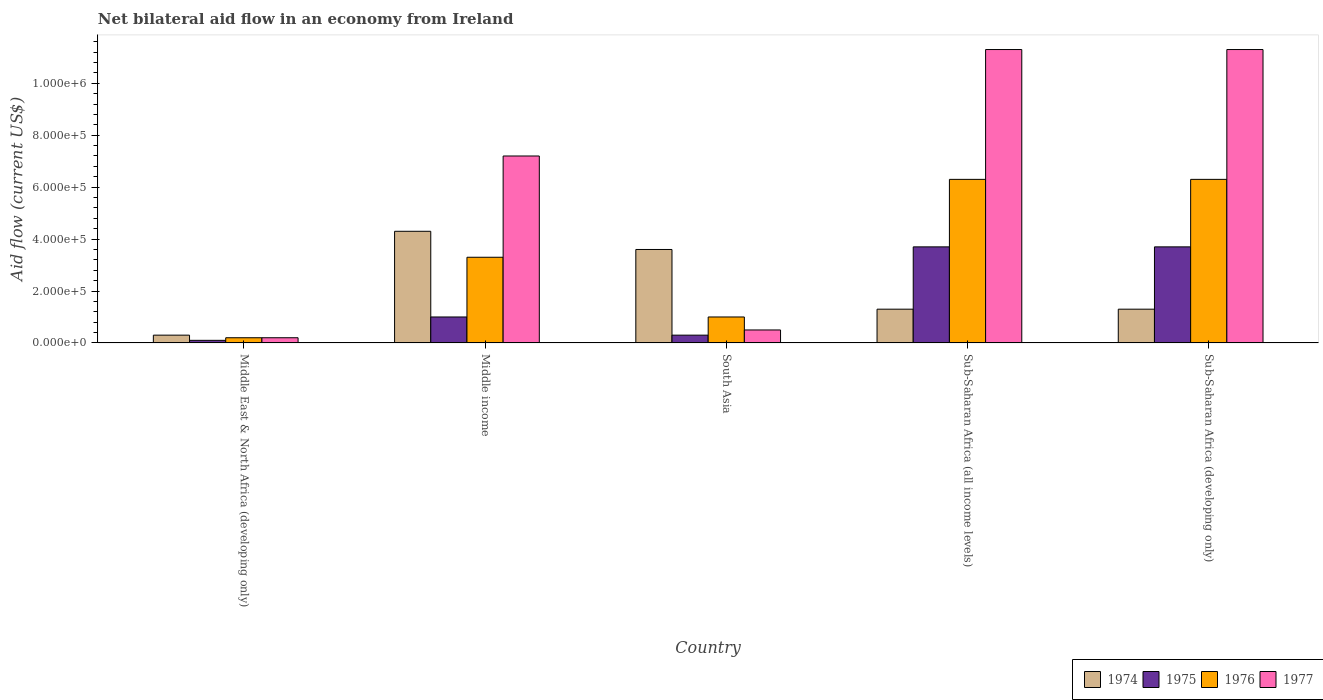How many different coloured bars are there?
Your answer should be very brief. 4. Are the number of bars on each tick of the X-axis equal?
Your response must be concise. Yes. What is the label of the 2nd group of bars from the left?
Give a very brief answer. Middle income. In how many cases, is the number of bars for a given country not equal to the number of legend labels?
Offer a terse response. 0. What is the net bilateral aid flow in 1977 in Middle income?
Provide a short and direct response. 7.20e+05. Across all countries, what is the maximum net bilateral aid flow in 1974?
Offer a terse response. 4.30e+05. Across all countries, what is the minimum net bilateral aid flow in 1976?
Provide a succinct answer. 2.00e+04. In which country was the net bilateral aid flow in 1975 maximum?
Offer a very short reply. Sub-Saharan Africa (all income levels). In which country was the net bilateral aid flow in 1976 minimum?
Offer a terse response. Middle East & North Africa (developing only). What is the total net bilateral aid flow in 1977 in the graph?
Give a very brief answer. 3.05e+06. What is the difference between the net bilateral aid flow in 1976 in South Asia and that in Sub-Saharan Africa (developing only)?
Ensure brevity in your answer.  -5.30e+05. What is the difference between the net bilateral aid flow in 1974 in Sub-Saharan Africa (all income levels) and the net bilateral aid flow in 1977 in Middle East & North Africa (developing only)?
Your response must be concise. 1.10e+05. What is the average net bilateral aid flow in 1976 per country?
Make the answer very short. 3.42e+05. What is the difference between the net bilateral aid flow of/in 1976 and net bilateral aid flow of/in 1977 in Sub-Saharan Africa (all income levels)?
Offer a terse response. -5.00e+05. What is the ratio of the net bilateral aid flow in 1974 in South Asia to that in Sub-Saharan Africa (developing only)?
Make the answer very short. 2.77. Is the difference between the net bilateral aid flow in 1976 in Middle income and South Asia greater than the difference between the net bilateral aid flow in 1977 in Middle income and South Asia?
Give a very brief answer. No. What is the difference between the highest and the lowest net bilateral aid flow in 1976?
Provide a succinct answer. 6.10e+05. Is the sum of the net bilateral aid flow in 1975 in South Asia and Sub-Saharan Africa (all income levels) greater than the maximum net bilateral aid flow in 1974 across all countries?
Keep it short and to the point. No. What does the 1st bar from the left in Sub-Saharan Africa (developing only) represents?
Provide a short and direct response. 1974. What does the 4th bar from the right in Middle income represents?
Your answer should be compact. 1974. Does the graph contain grids?
Keep it short and to the point. No. Where does the legend appear in the graph?
Your answer should be compact. Bottom right. What is the title of the graph?
Offer a very short reply. Net bilateral aid flow in an economy from Ireland. Does "1974" appear as one of the legend labels in the graph?
Your response must be concise. Yes. What is the label or title of the X-axis?
Offer a terse response. Country. What is the label or title of the Y-axis?
Ensure brevity in your answer.  Aid flow (current US$). What is the Aid flow (current US$) of 1974 in Middle East & North Africa (developing only)?
Offer a terse response. 3.00e+04. What is the Aid flow (current US$) in 1977 in Middle East & North Africa (developing only)?
Your answer should be very brief. 2.00e+04. What is the Aid flow (current US$) of 1974 in Middle income?
Keep it short and to the point. 4.30e+05. What is the Aid flow (current US$) of 1976 in Middle income?
Provide a succinct answer. 3.30e+05. What is the Aid flow (current US$) of 1977 in Middle income?
Keep it short and to the point. 7.20e+05. What is the Aid flow (current US$) in 1974 in South Asia?
Your response must be concise. 3.60e+05. What is the Aid flow (current US$) in 1975 in South Asia?
Give a very brief answer. 3.00e+04. What is the Aid flow (current US$) of 1977 in South Asia?
Your answer should be compact. 5.00e+04. What is the Aid flow (current US$) in 1974 in Sub-Saharan Africa (all income levels)?
Your answer should be very brief. 1.30e+05. What is the Aid flow (current US$) in 1975 in Sub-Saharan Africa (all income levels)?
Provide a succinct answer. 3.70e+05. What is the Aid flow (current US$) of 1976 in Sub-Saharan Africa (all income levels)?
Offer a very short reply. 6.30e+05. What is the Aid flow (current US$) of 1977 in Sub-Saharan Africa (all income levels)?
Offer a very short reply. 1.13e+06. What is the Aid flow (current US$) in 1975 in Sub-Saharan Africa (developing only)?
Provide a short and direct response. 3.70e+05. What is the Aid flow (current US$) in 1976 in Sub-Saharan Africa (developing only)?
Your answer should be very brief. 6.30e+05. What is the Aid flow (current US$) in 1977 in Sub-Saharan Africa (developing only)?
Provide a succinct answer. 1.13e+06. Across all countries, what is the maximum Aid flow (current US$) of 1975?
Your answer should be compact. 3.70e+05. Across all countries, what is the maximum Aid flow (current US$) of 1976?
Ensure brevity in your answer.  6.30e+05. Across all countries, what is the maximum Aid flow (current US$) in 1977?
Your answer should be very brief. 1.13e+06. Across all countries, what is the minimum Aid flow (current US$) of 1976?
Keep it short and to the point. 2.00e+04. Across all countries, what is the minimum Aid flow (current US$) in 1977?
Keep it short and to the point. 2.00e+04. What is the total Aid flow (current US$) of 1974 in the graph?
Offer a very short reply. 1.08e+06. What is the total Aid flow (current US$) in 1975 in the graph?
Keep it short and to the point. 8.80e+05. What is the total Aid flow (current US$) in 1976 in the graph?
Give a very brief answer. 1.71e+06. What is the total Aid flow (current US$) in 1977 in the graph?
Offer a terse response. 3.05e+06. What is the difference between the Aid flow (current US$) of 1974 in Middle East & North Africa (developing only) and that in Middle income?
Provide a short and direct response. -4.00e+05. What is the difference between the Aid flow (current US$) in 1975 in Middle East & North Africa (developing only) and that in Middle income?
Provide a short and direct response. -9.00e+04. What is the difference between the Aid flow (current US$) of 1976 in Middle East & North Africa (developing only) and that in Middle income?
Your answer should be very brief. -3.10e+05. What is the difference between the Aid flow (current US$) of 1977 in Middle East & North Africa (developing only) and that in Middle income?
Keep it short and to the point. -7.00e+05. What is the difference between the Aid flow (current US$) in 1974 in Middle East & North Africa (developing only) and that in South Asia?
Give a very brief answer. -3.30e+05. What is the difference between the Aid flow (current US$) in 1975 in Middle East & North Africa (developing only) and that in South Asia?
Your response must be concise. -2.00e+04. What is the difference between the Aid flow (current US$) of 1977 in Middle East & North Africa (developing only) and that in South Asia?
Ensure brevity in your answer.  -3.00e+04. What is the difference between the Aid flow (current US$) in 1975 in Middle East & North Africa (developing only) and that in Sub-Saharan Africa (all income levels)?
Your response must be concise. -3.60e+05. What is the difference between the Aid flow (current US$) in 1976 in Middle East & North Africa (developing only) and that in Sub-Saharan Africa (all income levels)?
Give a very brief answer. -6.10e+05. What is the difference between the Aid flow (current US$) of 1977 in Middle East & North Africa (developing only) and that in Sub-Saharan Africa (all income levels)?
Make the answer very short. -1.11e+06. What is the difference between the Aid flow (current US$) in 1974 in Middle East & North Africa (developing only) and that in Sub-Saharan Africa (developing only)?
Offer a terse response. -1.00e+05. What is the difference between the Aid flow (current US$) of 1975 in Middle East & North Africa (developing only) and that in Sub-Saharan Africa (developing only)?
Offer a very short reply. -3.60e+05. What is the difference between the Aid flow (current US$) in 1976 in Middle East & North Africa (developing only) and that in Sub-Saharan Africa (developing only)?
Provide a short and direct response. -6.10e+05. What is the difference between the Aid flow (current US$) of 1977 in Middle East & North Africa (developing only) and that in Sub-Saharan Africa (developing only)?
Keep it short and to the point. -1.11e+06. What is the difference between the Aid flow (current US$) of 1975 in Middle income and that in South Asia?
Ensure brevity in your answer.  7.00e+04. What is the difference between the Aid flow (current US$) in 1977 in Middle income and that in South Asia?
Your response must be concise. 6.70e+05. What is the difference between the Aid flow (current US$) of 1974 in Middle income and that in Sub-Saharan Africa (all income levels)?
Your answer should be very brief. 3.00e+05. What is the difference between the Aid flow (current US$) of 1976 in Middle income and that in Sub-Saharan Africa (all income levels)?
Provide a succinct answer. -3.00e+05. What is the difference between the Aid flow (current US$) of 1977 in Middle income and that in Sub-Saharan Africa (all income levels)?
Ensure brevity in your answer.  -4.10e+05. What is the difference between the Aid flow (current US$) of 1976 in Middle income and that in Sub-Saharan Africa (developing only)?
Your answer should be very brief. -3.00e+05. What is the difference between the Aid flow (current US$) in 1977 in Middle income and that in Sub-Saharan Africa (developing only)?
Offer a very short reply. -4.10e+05. What is the difference between the Aid flow (current US$) in 1976 in South Asia and that in Sub-Saharan Africa (all income levels)?
Your response must be concise. -5.30e+05. What is the difference between the Aid flow (current US$) in 1977 in South Asia and that in Sub-Saharan Africa (all income levels)?
Provide a short and direct response. -1.08e+06. What is the difference between the Aid flow (current US$) of 1974 in South Asia and that in Sub-Saharan Africa (developing only)?
Provide a short and direct response. 2.30e+05. What is the difference between the Aid flow (current US$) of 1975 in South Asia and that in Sub-Saharan Africa (developing only)?
Offer a very short reply. -3.40e+05. What is the difference between the Aid flow (current US$) of 1976 in South Asia and that in Sub-Saharan Africa (developing only)?
Offer a terse response. -5.30e+05. What is the difference between the Aid flow (current US$) in 1977 in South Asia and that in Sub-Saharan Africa (developing only)?
Give a very brief answer. -1.08e+06. What is the difference between the Aid flow (current US$) in 1975 in Sub-Saharan Africa (all income levels) and that in Sub-Saharan Africa (developing only)?
Make the answer very short. 0. What is the difference between the Aid flow (current US$) in 1977 in Sub-Saharan Africa (all income levels) and that in Sub-Saharan Africa (developing only)?
Your answer should be very brief. 0. What is the difference between the Aid flow (current US$) in 1974 in Middle East & North Africa (developing only) and the Aid flow (current US$) in 1976 in Middle income?
Ensure brevity in your answer.  -3.00e+05. What is the difference between the Aid flow (current US$) in 1974 in Middle East & North Africa (developing only) and the Aid flow (current US$) in 1977 in Middle income?
Give a very brief answer. -6.90e+05. What is the difference between the Aid flow (current US$) in 1975 in Middle East & North Africa (developing only) and the Aid flow (current US$) in 1976 in Middle income?
Make the answer very short. -3.20e+05. What is the difference between the Aid flow (current US$) of 1975 in Middle East & North Africa (developing only) and the Aid flow (current US$) of 1977 in Middle income?
Your response must be concise. -7.10e+05. What is the difference between the Aid flow (current US$) in 1976 in Middle East & North Africa (developing only) and the Aid flow (current US$) in 1977 in Middle income?
Offer a very short reply. -7.00e+05. What is the difference between the Aid flow (current US$) of 1974 in Middle East & North Africa (developing only) and the Aid flow (current US$) of 1975 in South Asia?
Keep it short and to the point. 0. What is the difference between the Aid flow (current US$) in 1974 in Middle East & North Africa (developing only) and the Aid flow (current US$) in 1976 in South Asia?
Offer a very short reply. -7.00e+04. What is the difference between the Aid flow (current US$) of 1975 in Middle East & North Africa (developing only) and the Aid flow (current US$) of 1976 in South Asia?
Provide a succinct answer. -9.00e+04. What is the difference between the Aid flow (current US$) in 1974 in Middle East & North Africa (developing only) and the Aid flow (current US$) in 1976 in Sub-Saharan Africa (all income levels)?
Offer a terse response. -6.00e+05. What is the difference between the Aid flow (current US$) in 1974 in Middle East & North Africa (developing only) and the Aid flow (current US$) in 1977 in Sub-Saharan Africa (all income levels)?
Make the answer very short. -1.10e+06. What is the difference between the Aid flow (current US$) of 1975 in Middle East & North Africa (developing only) and the Aid flow (current US$) of 1976 in Sub-Saharan Africa (all income levels)?
Your response must be concise. -6.20e+05. What is the difference between the Aid flow (current US$) in 1975 in Middle East & North Africa (developing only) and the Aid flow (current US$) in 1977 in Sub-Saharan Africa (all income levels)?
Your answer should be compact. -1.12e+06. What is the difference between the Aid flow (current US$) of 1976 in Middle East & North Africa (developing only) and the Aid flow (current US$) of 1977 in Sub-Saharan Africa (all income levels)?
Your answer should be very brief. -1.11e+06. What is the difference between the Aid flow (current US$) in 1974 in Middle East & North Africa (developing only) and the Aid flow (current US$) in 1976 in Sub-Saharan Africa (developing only)?
Offer a very short reply. -6.00e+05. What is the difference between the Aid flow (current US$) in 1974 in Middle East & North Africa (developing only) and the Aid flow (current US$) in 1977 in Sub-Saharan Africa (developing only)?
Your answer should be compact. -1.10e+06. What is the difference between the Aid flow (current US$) of 1975 in Middle East & North Africa (developing only) and the Aid flow (current US$) of 1976 in Sub-Saharan Africa (developing only)?
Give a very brief answer. -6.20e+05. What is the difference between the Aid flow (current US$) of 1975 in Middle East & North Africa (developing only) and the Aid flow (current US$) of 1977 in Sub-Saharan Africa (developing only)?
Give a very brief answer. -1.12e+06. What is the difference between the Aid flow (current US$) of 1976 in Middle East & North Africa (developing only) and the Aid flow (current US$) of 1977 in Sub-Saharan Africa (developing only)?
Ensure brevity in your answer.  -1.11e+06. What is the difference between the Aid flow (current US$) in 1974 in Middle income and the Aid flow (current US$) in 1975 in South Asia?
Provide a succinct answer. 4.00e+05. What is the difference between the Aid flow (current US$) of 1974 in Middle income and the Aid flow (current US$) of 1975 in Sub-Saharan Africa (all income levels)?
Provide a short and direct response. 6.00e+04. What is the difference between the Aid flow (current US$) of 1974 in Middle income and the Aid flow (current US$) of 1976 in Sub-Saharan Africa (all income levels)?
Give a very brief answer. -2.00e+05. What is the difference between the Aid flow (current US$) in 1974 in Middle income and the Aid flow (current US$) in 1977 in Sub-Saharan Africa (all income levels)?
Provide a succinct answer. -7.00e+05. What is the difference between the Aid flow (current US$) in 1975 in Middle income and the Aid flow (current US$) in 1976 in Sub-Saharan Africa (all income levels)?
Ensure brevity in your answer.  -5.30e+05. What is the difference between the Aid flow (current US$) of 1975 in Middle income and the Aid flow (current US$) of 1977 in Sub-Saharan Africa (all income levels)?
Your answer should be compact. -1.03e+06. What is the difference between the Aid flow (current US$) in 1976 in Middle income and the Aid flow (current US$) in 1977 in Sub-Saharan Africa (all income levels)?
Your answer should be very brief. -8.00e+05. What is the difference between the Aid flow (current US$) in 1974 in Middle income and the Aid flow (current US$) in 1976 in Sub-Saharan Africa (developing only)?
Give a very brief answer. -2.00e+05. What is the difference between the Aid flow (current US$) in 1974 in Middle income and the Aid flow (current US$) in 1977 in Sub-Saharan Africa (developing only)?
Offer a very short reply. -7.00e+05. What is the difference between the Aid flow (current US$) of 1975 in Middle income and the Aid flow (current US$) of 1976 in Sub-Saharan Africa (developing only)?
Your response must be concise. -5.30e+05. What is the difference between the Aid flow (current US$) in 1975 in Middle income and the Aid flow (current US$) in 1977 in Sub-Saharan Africa (developing only)?
Your response must be concise. -1.03e+06. What is the difference between the Aid flow (current US$) of 1976 in Middle income and the Aid flow (current US$) of 1977 in Sub-Saharan Africa (developing only)?
Provide a succinct answer. -8.00e+05. What is the difference between the Aid flow (current US$) of 1974 in South Asia and the Aid flow (current US$) of 1977 in Sub-Saharan Africa (all income levels)?
Make the answer very short. -7.70e+05. What is the difference between the Aid flow (current US$) of 1975 in South Asia and the Aid flow (current US$) of 1976 in Sub-Saharan Africa (all income levels)?
Your answer should be compact. -6.00e+05. What is the difference between the Aid flow (current US$) of 1975 in South Asia and the Aid flow (current US$) of 1977 in Sub-Saharan Africa (all income levels)?
Your response must be concise. -1.10e+06. What is the difference between the Aid flow (current US$) in 1976 in South Asia and the Aid flow (current US$) in 1977 in Sub-Saharan Africa (all income levels)?
Your answer should be very brief. -1.03e+06. What is the difference between the Aid flow (current US$) of 1974 in South Asia and the Aid flow (current US$) of 1977 in Sub-Saharan Africa (developing only)?
Ensure brevity in your answer.  -7.70e+05. What is the difference between the Aid flow (current US$) of 1975 in South Asia and the Aid flow (current US$) of 1976 in Sub-Saharan Africa (developing only)?
Your response must be concise. -6.00e+05. What is the difference between the Aid flow (current US$) of 1975 in South Asia and the Aid flow (current US$) of 1977 in Sub-Saharan Africa (developing only)?
Your response must be concise. -1.10e+06. What is the difference between the Aid flow (current US$) of 1976 in South Asia and the Aid flow (current US$) of 1977 in Sub-Saharan Africa (developing only)?
Give a very brief answer. -1.03e+06. What is the difference between the Aid flow (current US$) of 1974 in Sub-Saharan Africa (all income levels) and the Aid flow (current US$) of 1975 in Sub-Saharan Africa (developing only)?
Provide a short and direct response. -2.40e+05. What is the difference between the Aid flow (current US$) of 1974 in Sub-Saharan Africa (all income levels) and the Aid flow (current US$) of 1976 in Sub-Saharan Africa (developing only)?
Your response must be concise. -5.00e+05. What is the difference between the Aid flow (current US$) in 1975 in Sub-Saharan Africa (all income levels) and the Aid flow (current US$) in 1976 in Sub-Saharan Africa (developing only)?
Keep it short and to the point. -2.60e+05. What is the difference between the Aid flow (current US$) of 1975 in Sub-Saharan Africa (all income levels) and the Aid flow (current US$) of 1977 in Sub-Saharan Africa (developing only)?
Make the answer very short. -7.60e+05. What is the difference between the Aid flow (current US$) of 1976 in Sub-Saharan Africa (all income levels) and the Aid flow (current US$) of 1977 in Sub-Saharan Africa (developing only)?
Make the answer very short. -5.00e+05. What is the average Aid flow (current US$) in 1974 per country?
Provide a short and direct response. 2.16e+05. What is the average Aid flow (current US$) of 1975 per country?
Your response must be concise. 1.76e+05. What is the average Aid flow (current US$) in 1976 per country?
Give a very brief answer. 3.42e+05. What is the difference between the Aid flow (current US$) in 1974 and Aid flow (current US$) in 1977 in Middle East & North Africa (developing only)?
Give a very brief answer. 10000. What is the difference between the Aid flow (current US$) of 1976 and Aid flow (current US$) of 1977 in Middle East & North Africa (developing only)?
Your answer should be compact. 0. What is the difference between the Aid flow (current US$) of 1974 and Aid flow (current US$) of 1975 in Middle income?
Your answer should be very brief. 3.30e+05. What is the difference between the Aid flow (current US$) in 1974 and Aid flow (current US$) in 1976 in Middle income?
Your answer should be very brief. 1.00e+05. What is the difference between the Aid flow (current US$) in 1975 and Aid flow (current US$) in 1976 in Middle income?
Give a very brief answer. -2.30e+05. What is the difference between the Aid flow (current US$) of 1975 and Aid flow (current US$) of 1977 in Middle income?
Give a very brief answer. -6.20e+05. What is the difference between the Aid flow (current US$) in 1976 and Aid flow (current US$) in 1977 in Middle income?
Provide a short and direct response. -3.90e+05. What is the difference between the Aid flow (current US$) in 1974 and Aid flow (current US$) in 1976 in South Asia?
Your answer should be compact. 2.60e+05. What is the difference between the Aid flow (current US$) of 1975 and Aid flow (current US$) of 1977 in South Asia?
Your answer should be compact. -2.00e+04. What is the difference between the Aid flow (current US$) of 1974 and Aid flow (current US$) of 1976 in Sub-Saharan Africa (all income levels)?
Give a very brief answer. -5.00e+05. What is the difference between the Aid flow (current US$) of 1974 and Aid flow (current US$) of 1977 in Sub-Saharan Africa (all income levels)?
Offer a terse response. -1.00e+06. What is the difference between the Aid flow (current US$) of 1975 and Aid flow (current US$) of 1977 in Sub-Saharan Africa (all income levels)?
Your answer should be very brief. -7.60e+05. What is the difference between the Aid flow (current US$) in 1976 and Aid flow (current US$) in 1977 in Sub-Saharan Africa (all income levels)?
Keep it short and to the point. -5.00e+05. What is the difference between the Aid flow (current US$) of 1974 and Aid flow (current US$) of 1975 in Sub-Saharan Africa (developing only)?
Provide a short and direct response. -2.40e+05. What is the difference between the Aid flow (current US$) of 1974 and Aid flow (current US$) of 1976 in Sub-Saharan Africa (developing only)?
Ensure brevity in your answer.  -5.00e+05. What is the difference between the Aid flow (current US$) in 1974 and Aid flow (current US$) in 1977 in Sub-Saharan Africa (developing only)?
Make the answer very short. -1.00e+06. What is the difference between the Aid flow (current US$) of 1975 and Aid flow (current US$) of 1976 in Sub-Saharan Africa (developing only)?
Make the answer very short. -2.60e+05. What is the difference between the Aid flow (current US$) in 1975 and Aid flow (current US$) in 1977 in Sub-Saharan Africa (developing only)?
Make the answer very short. -7.60e+05. What is the difference between the Aid flow (current US$) of 1976 and Aid flow (current US$) of 1977 in Sub-Saharan Africa (developing only)?
Provide a short and direct response. -5.00e+05. What is the ratio of the Aid flow (current US$) in 1974 in Middle East & North Africa (developing only) to that in Middle income?
Keep it short and to the point. 0.07. What is the ratio of the Aid flow (current US$) in 1975 in Middle East & North Africa (developing only) to that in Middle income?
Ensure brevity in your answer.  0.1. What is the ratio of the Aid flow (current US$) in 1976 in Middle East & North Africa (developing only) to that in Middle income?
Make the answer very short. 0.06. What is the ratio of the Aid flow (current US$) of 1977 in Middle East & North Africa (developing only) to that in Middle income?
Offer a terse response. 0.03. What is the ratio of the Aid flow (current US$) of 1974 in Middle East & North Africa (developing only) to that in South Asia?
Your response must be concise. 0.08. What is the ratio of the Aid flow (current US$) of 1976 in Middle East & North Africa (developing only) to that in South Asia?
Provide a short and direct response. 0.2. What is the ratio of the Aid flow (current US$) in 1974 in Middle East & North Africa (developing only) to that in Sub-Saharan Africa (all income levels)?
Your answer should be compact. 0.23. What is the ratio of the Aid flow (current US$) in 1975 in Middle East & North Africa (developing only) to that in Sub-Saharan Africa (all income levels)?
Offer a terse response. 0.03. What is the ratio of the Aid flow (current US$) in 1976 in Middle East & North Africa (developing only) to that in Sub-Saharan Africa (all income levels)?
Provide a short and direct response. 0.03. What is the ratio of the Aid flow (current US$) in 1977 in Middle East & North Africa (developing only) to that in Sub-Saharan Africa (all income levels)?
Your answer should be very brief. 0.02. What is the ratio of the Aid flow (current US$) in 1974 in Middle East & North Africa (developing only) to that in Sub-Saharan Africa (developing only)?
Make the answer very short. 0.23. What is the ratio of the Aid flow (current US$) of 1975 in Middle East & North Africa (developing only) to that in Sub-Saharan Africa (developing only)?
Ensure brevity in your answer.  0.03. What is the ratio of the Aid flow (current US$) in 1976 in Middle East & North Africa (developing only) to that in Sub-Saharan Africa (developing only)?
Your answer should be very brief. 0.03. What is the ratio of the Aid flow (current US$) of 1977 in Middle East & North Africa (developing only) to that in Sub-Saharan Africa (developing only)?
Offer a terse response. 0.02. What is the ratio of the Aid flow (current US$) in 1974 in Middle income to that in South Asia?
Offer a very short reply. 1.19. What is the ratio of the Aid flow (current US$) of 1975 in Middle income to that in South Asia?
Ensure brevity in your answer.  3.33. What is the ratio of the Aid flow (current US$) of 1977 in Middle income to that in South Asia?
Provide a short and direct response. 14.4. What is the ratio of the Aid flow (current US$) in 1974 in Middle income to that in Sub-Saharan Africa (all income levels)?
Offer a very short reply. 3.31. What is the ratio of the Aid flow (current US$) in 1975 in Middle income to that in Sub-Saharan Africa (all income levels)?
Provide a succinct answer. 0.27. What is the ratio of the Aid flow (current US$) in 1976 in Middle income to that in Sub-Saharan Africa (all income levels)?
Ensure brevity in your answer.  0.52. What is the ratio of the Aid flow (current US$) of 1977 in Middle income to that in Sub-Saharan Africa (all income levels)?
Offer a very short reply. 0.64. What is the ratio of the Aid flow (current US$) of 1974 in Middle income to that in Sub-Saharan Africa (developing only)?
Provide a succinct answer. 3.31. What is the ratio of the Aid flow (current US$) in 1975 in Middle income to that in Sub-Saharan Africa (developing only)?
Your answer should be compact. 0.27. What is the ratio of the Aid flow (current US$) in 1976 in Middle income to that in Sub-Saharan Africa (developing only)?
Your response must be concise. 0.52. What is the ratio of the Aid flow (current US$) of 1977 in Middle income to that in Sub-Saharan Africa (developing only)?
Offer a terse response. 0.64. What is the ratio of the Aid flow (current US$) in 1974 in South Asia to that in Sub-Saharan Africa (all income levels)?
Your answer should be very brief. 2.77. What is the ratio of the Aid flow (current US$) in 1975 in South Asia to that in Sub-Saharan Africa (all income levels)?
Your answer should be very brief. 0.08. What is the ratio of the Aid flow (current US$) in 1976 in South Asia to that in Sub-Saharan Africa (all income levels)?
Offer a very short reply. 0.16. What is the ratio of the Aid flow (current US$) in 1977 in South Asia to that in Sub-Saharan Africa (all income levels)?
Provide a succinct answer. 0.04. What is the ratio of the Aid flow (current US$) in 1974 in South Asia to that in Sub-Saharan Africa (developing only)?
Provide a short and direct response. 2.77. What is the ratio of the Aid flow (current US$) in 1975 in South Asia to that in Sub-Saharan Africa (developing only)?
Ensure brevity in your answer.  0.08. What is the ratio of the Aid flow (current US$) in 1976 in South Asia to that in Sub-Saharan Africa (developing only)?
Your answer should be very brief. 0.16. What is the ratio of the Aid flow (current US$) of 1977 in South Asia to that in Sub-Saharan Africa (developing only)?
Keep it short and to the point. 0.04. What is the ratio of the Aid flow (current US$) in 1976 in Sub-Saharan Africa (all income levels) to that in Sub-Saharan Africa (developing only)?
Your response must be concise. 1. What is the ratio of the Aid flow (current US$) in 1977 in Sub-Saharan Africa (all income levels) to that in Sub-Saharan Africa (developing only)?
Your answer should be very brief. 1. What is the difference between the highest and the second highest Aid flow (current US$) in 1977?
Keep it short and to the point. 0. What is the difference between the highest and the lowest Aid flow (current US$) in 1975?
Provide a succinct answer. 3.60e+05. What is the difference between the highest and the lowest Aid flow (current US$) of 1977?
Provide a short and direct response. 1.11e+06. 